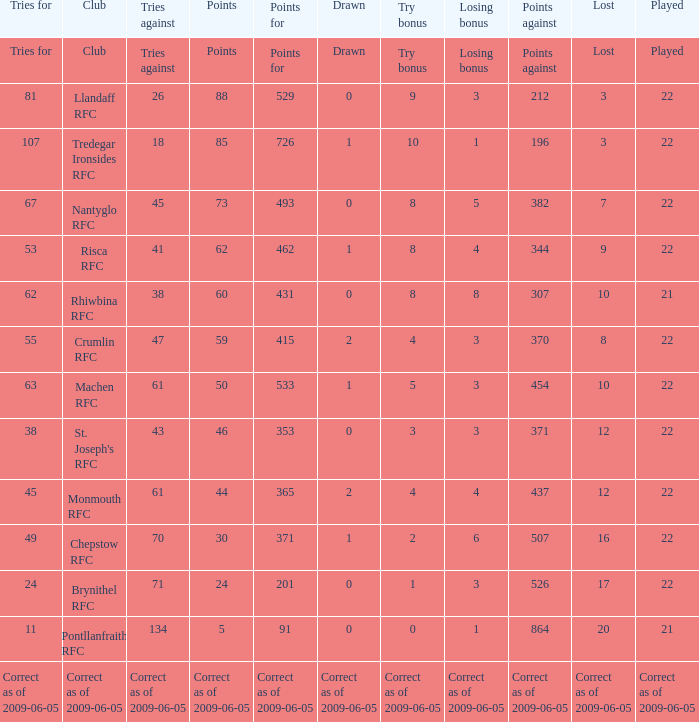If points against was 371, what is the drawn? 0.0. 